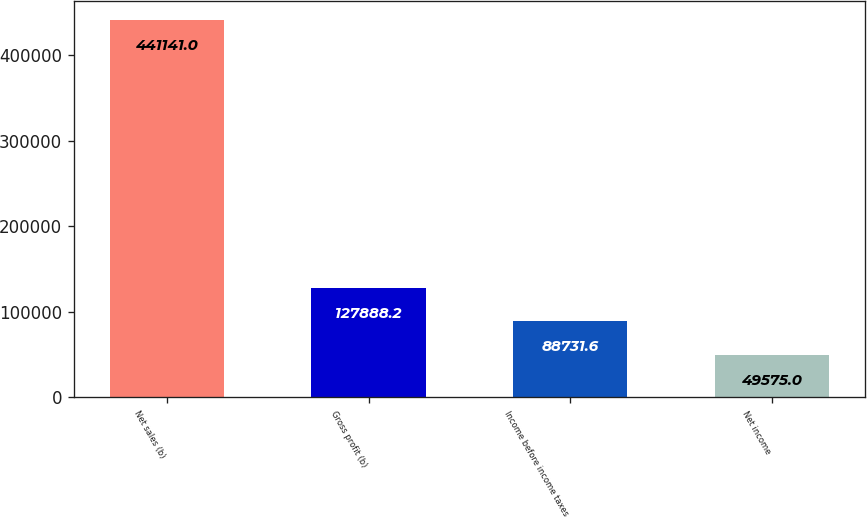<chart> <loc_0><loc_0><loc_500><loc_500><bar_chart><fcel>Net sales (b)<fcel>Gross profit (b)<fcel>Income before income taxes<fcel>Net income<nl><fcel>441141<fcel>127888<fcel>88731.6<fcel>49575<nl></chart> 